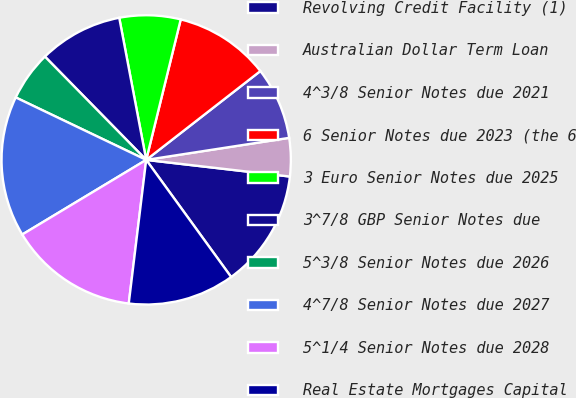Convert chart to OTSL. <chart><loc_0><loc_0><loc_500><loc_500><pie_chart><fcel>Revolving Credit Facility (1)<fcel>Australian Dollar Term Loan<fcel>4^3/8 Senior Notes due 2021<fcel>6 Senior Notes due 2023 (the 6<fcel>3 Euro Senior Notes due 2025<fcel>3^7/8 GBP Senior Notes due<fcel>5^3/8 Senior Notes due 2026<fcel>4^7/8 Senior Notes due 2027<fcel>5^1/4 Senior Notes due 2028<fcel>Real Estate Mortgages Capital<nl><fcel>13.18%<fcel>4.27%<fcel>8.09%<fcel>10.64%<fcel>6.82%<fcel>9.36%<fcel>5.55%<fcel>15.73%<fcel>14.45%<fcel>11.91%<nl></chart> 